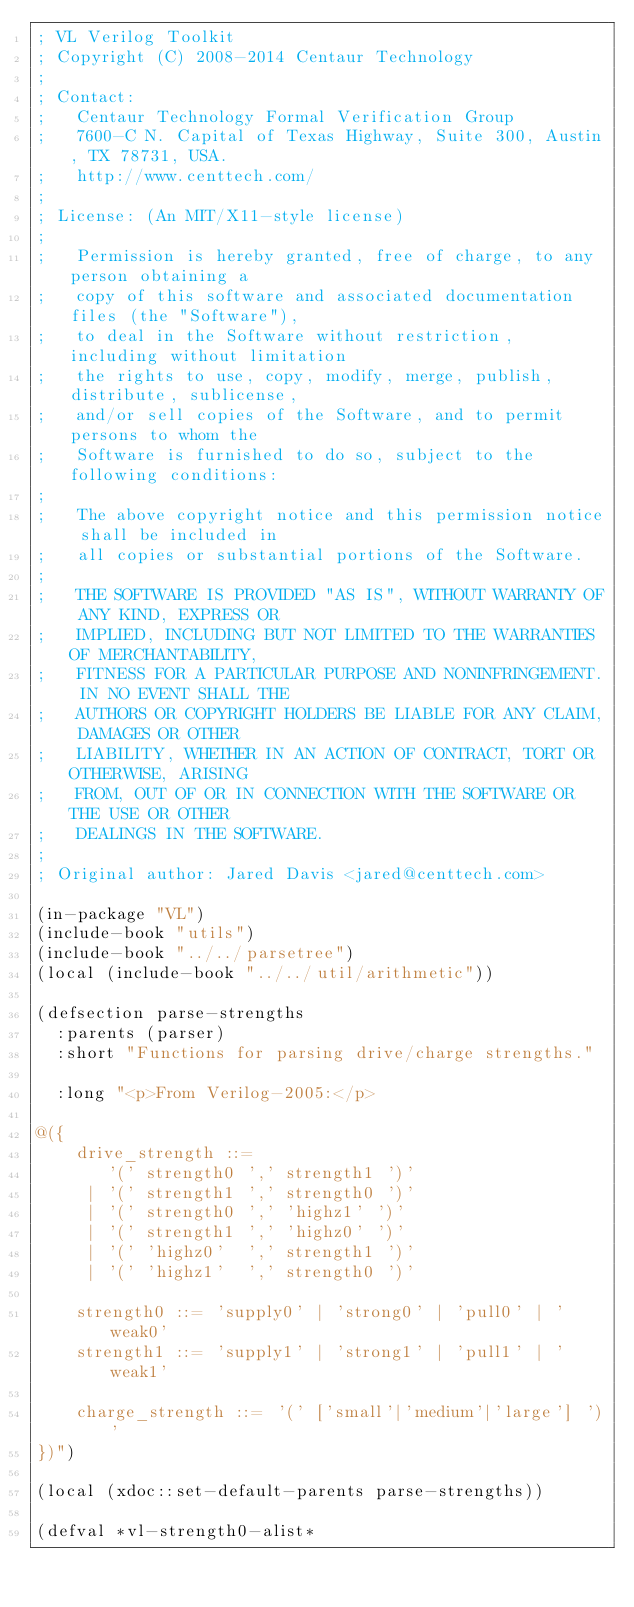Convert code to text. <code><loc_0><loc_0><loc_500><loc_500><_Lisp_>; VL Verilog Toolkit
; Copyright (C) 2008-2014 Centaur Technology
;
; Contact:
;   Centaur Technology Formal Verification Group
;   7600-C N. Capital of Texas Highway, Suite 300, Austin, TX 78731, USA.
;   http://www.centtech.com/
;
; License: (An MIT/X11-style license)
;
;   Permission is hereby granted, free of charge, to any person obtaining a
;   copy of this software and associated documentation files (the "Software"),
;   to deal in the Software without restriction, including without limitation
;   the rights to use, copy, modify, merge, publish, distribute, sublicense,
;   and/or sell copies of the Software, and to permit persons to whom the
;   Software is furnished to do so, subject to the following conditions:
;
;   The above copyright notice and this permission notice shall be included in
;   all copies or substantial portions of the Software.
;
;   THE SOFTWARE IS PROVIDED "AS IS", WITHOUT WARRANTY OF ANY KIND, EXPRESS OR
;   IMPLIED, INCLUDING BUT NOT LIMITED TO THE WARRANTIES OF MERCHANTABILITY,
;   FITNESS FOR A PARTICULAR PURPOSE AND NONINFRINGEMENT. IN NO EVENT SHALL THE
;   AUTHORS OR COPYRIGHT HOLDERS BE LIABLE FOR ANY CLAIM, DAMAGES OR OTHER
;   LIABILITY, WHETHER IN AN ACTION OF CONTRACT, TORT OR OTHERWISE, ARISING
;   FROM, OUT OF OR IN CONNECTION WITH THE SOFTWARE OR THE USE OR OTHER
;   DEALINGS IN THE SOFTWARE.
;
; Original author: Jared Davis <jared@centtech.com>

(in-package "VL")
(include-book "utils")
(include-book "../../parsetree")
(local (include-book "../../util/arithmetic"))

(defsection parse-strengths
  :parents (parser)
  :short "Functions for parsing drive/charge strengths."

  :long "<p>From Verilog-2005:</p>

@({
    drive_strength ::=
       '(' strength0 ',' strength1 ')'
     | '(' strength1 ',' strength0 ')'
     | '(' strength0 ',' 'highz1' ')'
     | '(' strength1 ',' 'highz0' ')'
     | '(' 'highz0'  ',' strength1 ')'
     | '(' 'highz1'  ',' strength0 ')'

    strength0 ::= 'supply0' | 'strong0' | 'pull0' | 'weak0'
    strength1 ::= 'supply1' | 'strong1' | 'pull1' | 'weak1'

    charge_strength ::= '(' ['small'|'medium'|'large'] ')'
})")

(local (xdoc::set-default-parents parse-strengths))

(defval *vl-strength0-alist*</code> 